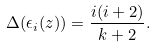Convert formula to latex. <formula><loc_0><loc_0><loc_500><loc_500>\Delta ( \epsilon _ { i } ( z ) ) = \frac { i ( i + 2 ) } { k + 2 } .</formula> 